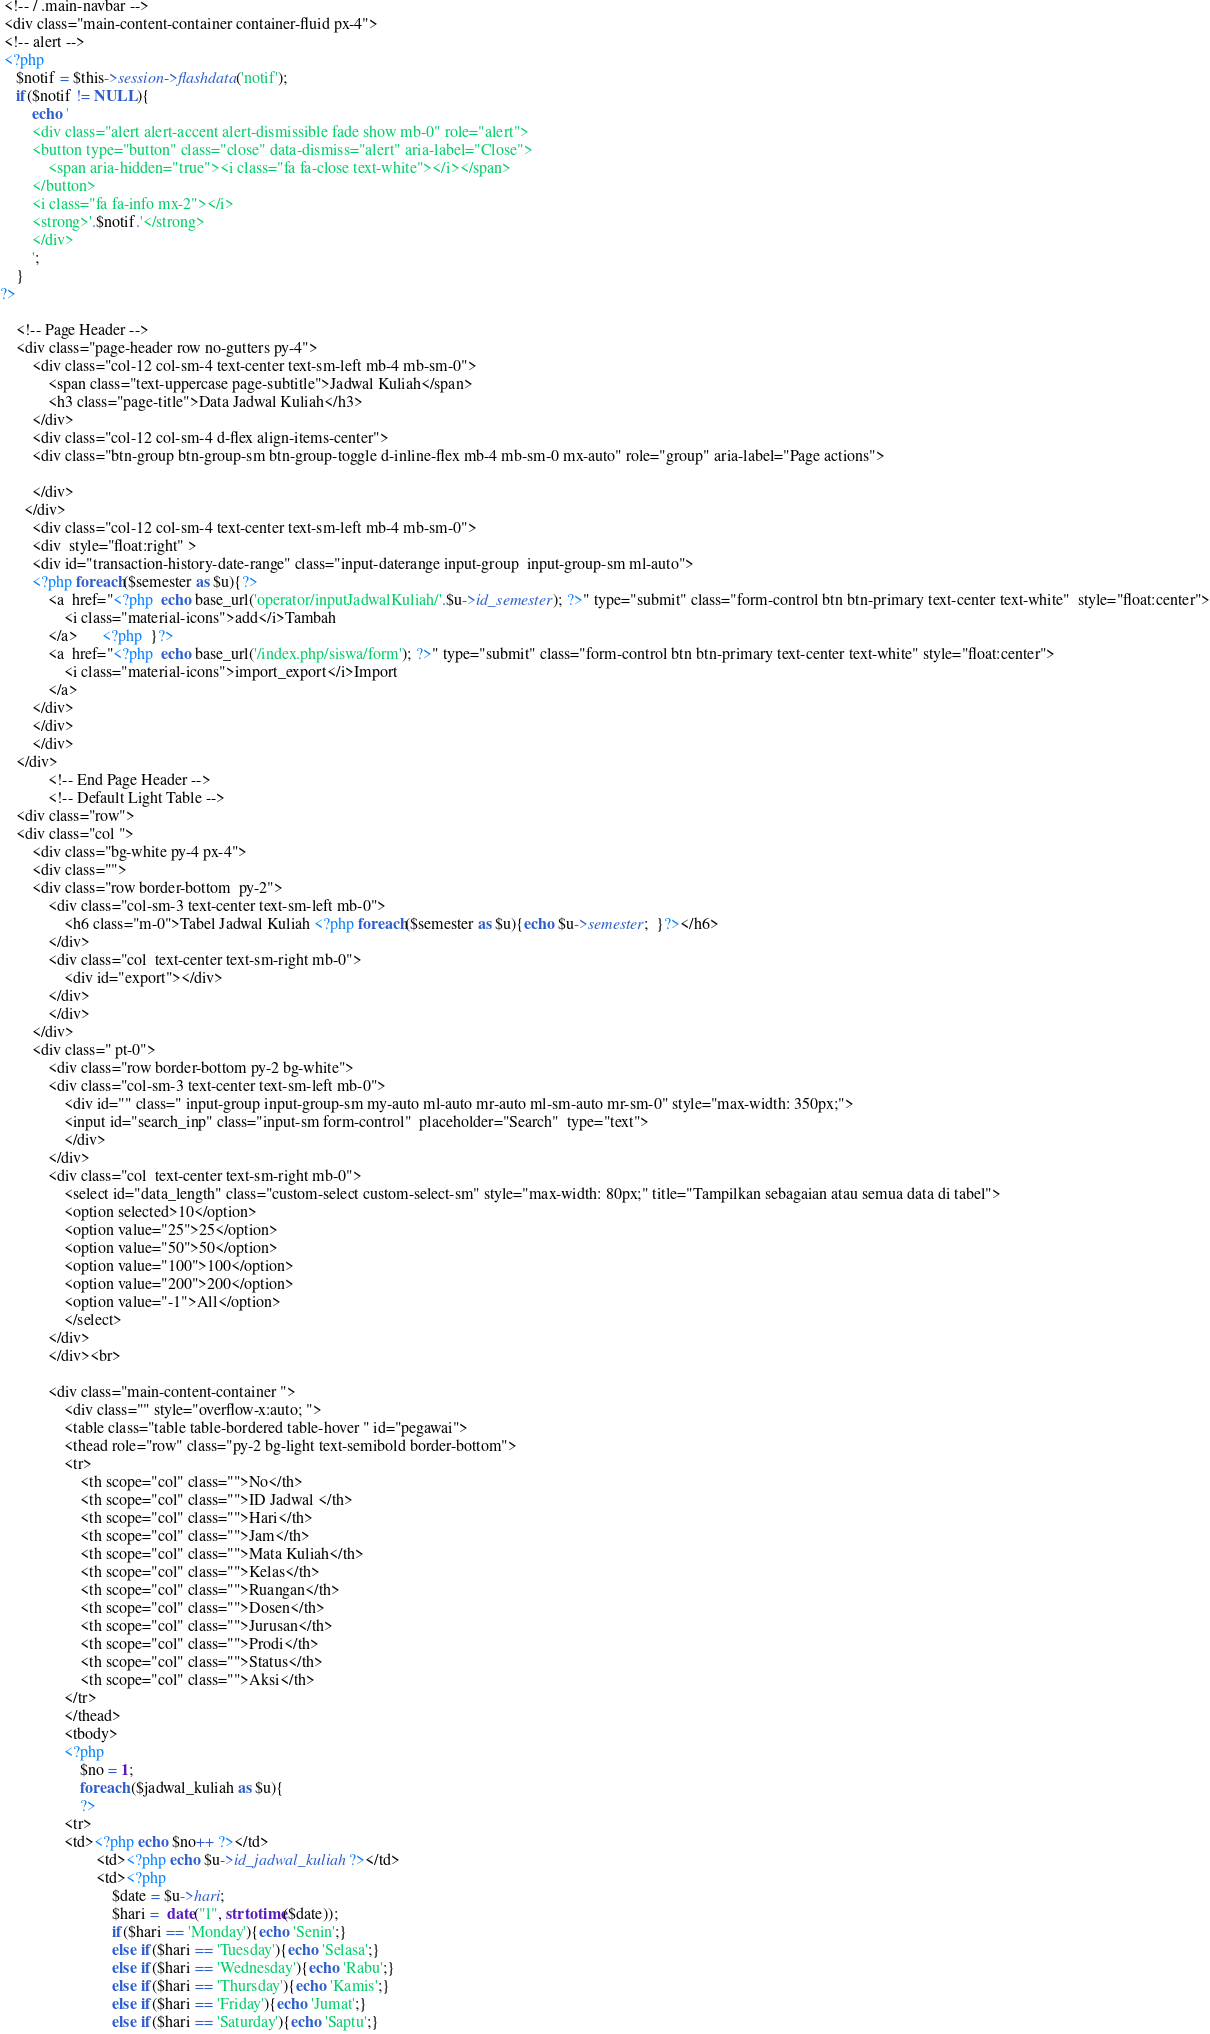Convert code to text. <code><loc_0><loc_0><loc_500><loc_500><_PHP_> <!-- / .main-navbar -->
 <div class="main-content-container container-fluid px-4">
 <!-- alert -->
 <?php
    $notif = $this->session->flashdata('notif');
    if($notif != NULL){
        echo '
        <div class="alert alert-accent alert-dismissible fade show mb-0" role="alert">
        <button type="button" class="close" data-dismiss="alert" aria-label="Close">
            <span aria-hidden="true"><i class="fa fa-close text-white"></i></span>
        </button>
        <i class="fa fa-info mx-2"></i>
        <strong>'.$notif.'</strong> 
        </div>
        ';
    }
?>
   
    <!-- Page Header -->
    <div class="page-header row no-gutters py-4">
        <div class="col-12 col-sm-4 text-center text-sm-left mb-4 mb-sm-0">
            <span class="text-uppercase page-subtitle">Jadwal Kuliah</span>
            <h3 class="page-title">Data Jadwal Kuliah</h3>
        </div>
        <div class="col-12 col-sm-4 d-flex align-items-center">
        <div class="btn-group btn-group-sm btn-group-toggle d-inline-flex mb-4 mb-sm-0 mx-auto" role="group" aria-label="Page actions">
          
        </div>
      </div>
        <div class="col-12 col-sm-4 text-center text-sm-left mb-4 mb-sm-0">
        <div  style="float:right" >
        <div id="transaction-history-date-range" class="input-daterange input-group  input-group-sm ml-auto">
        <?php foreach($semester as $u){?> 
            <a  href="<?php  echo base_url('operator/inputJadwalKuliah/'.$u->id_semester); ?>" type="submit" class="form-control btn btn-primary text-center text-white"  style="float:center">
                <i class="material-icons">add</i>Tambah
            </a>      <?php  }?>
            <a  href="<?php  echo base_url('/index.php/siswa/form'); ?>" type="submit" class="form-control btn btn-primary text-center text-white" style="float:center">
                <i class="material-icons">import_export</i>Import
            </a>
        </div>
        </div>
        </div>
    </div>
            <!-- End Page Header -->
            <!-- Default Light Table -->
    <div class="row">
    <div class="col ">
        <div class="bg-white py-4 px-4">
        <div class="">
        <div class="row border-bottom  py-2">
            <div class="col-sm-3 text-center text-sm-left mb-0">
                <h6 class="m-0">Tabel Jadwal Kuliah <?php foreach($semester as $u){echo $u->semester;  }?></h6>
            </div>
            <div class="col  text-center text-sm-right mb-0">
                <div id="export"></div>
            </div>
            </div>
        </div>
        <div class=" pt-0">
            <div class="row border-bottom py-2 bg-white">
            <div class="col-sm-3 text-center text-sm-left mb-0">
                <div id="" class=" input-group input-group-sm my-auto ml-auto mr-auto ml-sm-auto mr-sm-0" style="max-width: 350px;">
                <input id="search_inp" class="input-sm form-control"  placeholder="Search"  type="text">
                </div>
            </div>
            <div class="col  text-center text-sm-right mb-0">
                <select id="data_length" class="custom-select custom-select-sm" style="max-width: 80px;" title="Tampilkan sebagaian atau semua data di tabel">
                <option selected>10</option>
                <option value="25">25</option>
                <option value="50">50</option>
                <option value="100">100</option>
                <option value="200">200</option>
                <option value="-1">All</option>
                </select>
            </div>
            </div><br>
        
            <div class="main-content-container ">
                <div class="" style="overflow-x:auto; ">
                <table class="table table-bordered table-hover " id="pegawai">
                <thead role="row" class="py-2 bg-light text-semibold border-bottom">
                <tr>
                    <th scope="col" class="">No</th>
                    <th scope="col" class="">ID Jadwal </th>
                    <th scope="col" class="">Hari</th>
                    <th scope="col" class="">Jam</th>
                    <th scope="col" class="">Mata Kuliah</th>
                    <th scope="col" class="">Kelas</th>
                    <th scope="col" class="">Ruangan</th>
                    <th scope="col" class="">Dosen</th>
                    <th scope="col" class="">Jurusan</th>
                    <th scope="col" class="">Prodi</th>
                    <th scope="col" class="">Status</th>
                    <th scope="col" class="">Aksi</th>
                </tr>
                </thead>
                <tbody>
                <?php 
                    $no = 1;
                    foreach ($jadwal_kuliah as $u){ 
                    ?>
                <tr>
                <td><?php echo $no++ ?></td>
                        <td><?php echo $u->id_jadwal_kuliah ?></td>
                        <td><?php  
                            $date = $u->hari;
                            $hari =  date("l", strtotime($date));
                            if($hari == 'Monday'){echo 'Senin';}
                            else if($hari == 'Tuesday'){echo 'Selasa';}
                            else if($hari == 'Wednesday'){echo 'Rabu';}
                            else if($hari == 'Thursday'){echo 'Kamis';}
                            else if($hari == 'Friday'){echo 'Jumat';}
                            else if($hari == 'Saturday'){echo 'Saptu';}</code> 